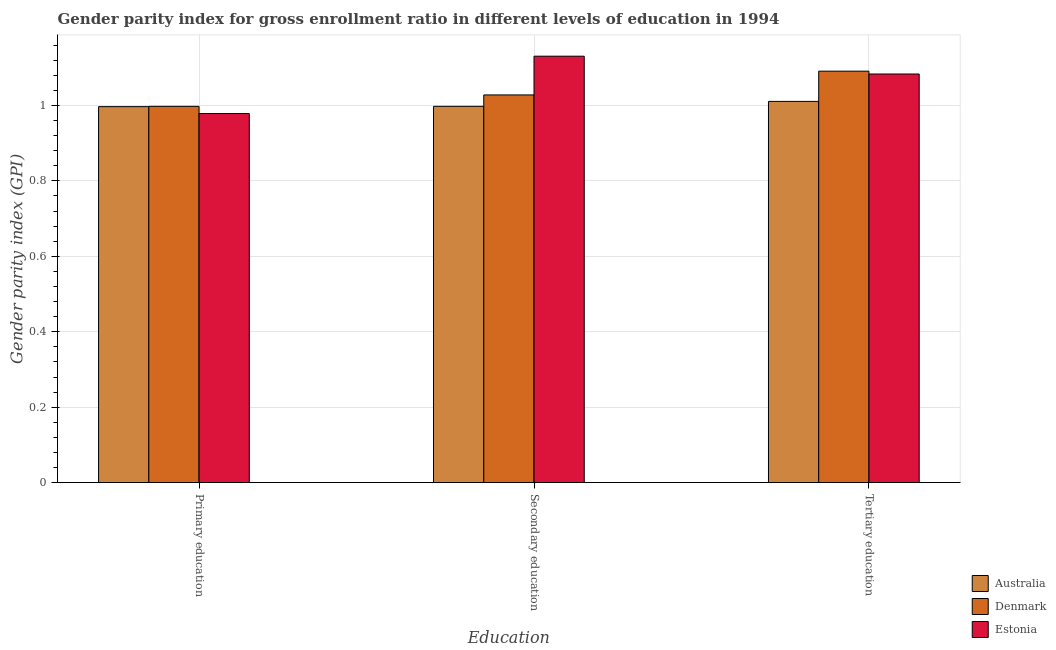How many groups of bars are there?
Ensure brevity in your answer.  3. Are the number of bars on each tick of the X-axis equal?
Your response must be concise. Yes. How many bars are there on the 3rd tick from the left?
Offer a terse response. 3. How many bars are there on the 2nd tick from the right?
Make the answer very short. 3. What is the label of the 3rd group of bars from the left?
Offer a very short reply. Tertiary education. What is the gender parity index in primary education in Denmark?
Your response must be concise. 1. Across all countries, what is the maximum gender parity index in tertiary education?
Make the answer very short. 1.09. Across all countries, what is the minimum gender parity index in secondary education?
Provide a short and direct response. 1. In which country was the gender parity index in tertiary education maximum?
Provide a short and direct response. Denmark. In which country was the gender parity index in tertiary education minimum?
Make the answer very short. Australia. What is the total gender parity index in secondary education in the graph?
Provide a succinct answer. 3.16. What is the difference between the gender parity index in tertiary education in Australia and that in Denmark?
Your answer should be compact. -0.08. What is the difference between the gender parity index in primary education in Denmark and the gender parity index in secondary education in Estonia?
Ensure brevity in your answer.  -0.13. What is the average gender parity index in tertiary education per country?
Offer a terse response. 1.06. What is the difference between the gender parity index in primary education and gender parity index in secondary education in Denmark?
Your response must be concise. -0.03. In how many countries, is the gender parity index in secondary education greater than 0.08 ?
Provide a succinct answer. 3. What is the ratio of the gender parity index in secondary education in Estonia to that in Australia?
Make the answer very short. 1.13. What is the difference between the highest and the second highest gender parity index in primary education?
Offer a terse response. 0. What is the difference between the highest and the lowest gender parity index in primary education?
Provide a short and direct response. 0.02. Is the sum of the gender parity index in secondary education in Denmark and Estonia greater than the maximum gender parity index in primary education across all countries?
Your answer should be very brief. Yes. What does the 3rd bar from the left in Primary education represents?
Give a very brief answer. Estonia. Are all the bars in the graph horizontal?
Offer a very short reply. No. Where does the legend appear in the graph?
Offer a very short reply. Bottom right. How are the legend labels stacked?
Ensure brevity in your answer.  Vertical. What is the title of the graph?
Make the answer very short. Gender parity index for gross enrollment ratio in different levels of education in 1994. What is the label or title of the X-axis?
Offer a very short reply. Education. What is the label or title of the Y-axis?
Offer a very short reply. Gender parity index (GPI). What is the Gender parity index (GPI) in Australia in Primary education?
Keep it short and to the point. 1. What is the Gender parity index (GPI) in Denmark in Primary education?
Provide a succinct answer. 1. What is the Gender parity index (GPI) in Estonia in Primary education?
Keep it short and to the point. 0.98. What is the Gender parity index (GPI) in Australia in Secondary education?
Make the answer very short. 1. What is the Gender parity index (GPI) in Denmark in Secondary education?
Keep it short and to the point. 1.03. What is the Gender parity index (GPI) of Estonia in Secondary education?
Provide a short and direct response. 1.13. What is the Gender parity index (GPI) of Australia in Tertiary education?
Make the answer very short. 1.01. What is the Gender parity index (GPI) of Denmark in Tertiary education?
Your response must be concise. 1.09. What is the Gender parity index (GPI) in Estonia in Tertiary education?
Keep it short and to the point. 1.08. Across all Education, what is the maximum Gender parity index (GPI) of Australia?
Your answer should be very brief. 1.01. Across all Education, what is the maximum Gender parity index (GPI) in Denmark?
Provide a short and direct response. 1.09. Across all Education, what is the maximum Gender parity index (GPI) in Estonia?
Keep it short and to the point. 1.13. Across all Education, what is the minimum Gender parity index (GPI) in Australia?
Make the answer very short. 1. Across all Education, what is the minimum Gender parity index (GPI) of Denmark?
Give a very brief answer. 1. Across all Education, what is the minimum Gender parity index (GPI) in Estonia?
Make the answer very short. 0.98. What is the total Gender parity index (GPI) in Australia in the graph?
Offer a very short reply. 3.01. What is the total Gender parity index (GPI) of Denmark in the graph?
Provide a short and direct response. 3.12. What is the total Gender parity index (GPI) in Estonia in the graph?
Your response must be concise. 3.19. What is the difference between the Gender parity index (GPI) of Australia in Primary education and that in Secondary education?
Keep it short and to the point. -0. What is the difference between the Gender parity index (GPI) of Denmark in Primary education and that in Secondary education?
Provide a short and direct response. -0.03. What is the difference between the Gender parity index (GPI) in Estonia in Primary education and that in Secondary education?
Ensure brevity in your answer.  -0.15. What is the difference between the Gender parity index (GPI) of Australia in Primary education and that in Tertiary education?
Provide a short and direct response. -0.01. What is the difference between the Gender parity index (GPI) of Denmark in Primary education and that in Tertiary education?
Your answer should be very brief. -0.09. What is the difference between the Gender parity index (GPI) of Estonia in Primary education and that in Tertiary education?
Give a very brief answer. -0.1. What is the difference between the Gender parity index (GPI) of Australia in Secondary education and that in Tertiary education?
Your response must be concise. -0.01. What is the difference between the Gender parity index (GPI) of Denmark in Secondary education and that in Tertiary education?
Keep it short and to the point. -0.06. What is the difference between the Gender parity index (GPI) of Estonia in Secondary education and that in Tertiary education?
Make the answer very short. 0.05. What is the difference between the Gender parity index (GPI) of Australia in Primary education and the Gender parity index (GPI) of Denmark in Secondary education?
Your answer should be very brief. -0.03. What is the difference between the Gender parity index (GPI) of Australia in Primary education and the Gender parity index (GPI) of Estonia in Secondary education?
Ensure brevity in your answer.  -0.13. What is the difference between the Gender parity index (GPI) of Denmark in Primary education and the Gender parity index (GPI) of Estonia in Secondary education?
Keep it short and to the point. -0.13. What is the difference between the Gender parity index (GPI) of Australia in Primary education and the Gender parity index (GPI) of Denmark in Tertiary education?
Keep it short and to the point. -0.09. What is the difference between the Gender parity index (GPI) in Australia in Primary education and the Gender parity index (GPI) in Estonia in Tertiary education?
Offer a very short reply. -0.09. What is the difference between the Gender parity index (GPI) of Denmark in Primary education and the Gender parity index (GPI) of Estonia in Tertiary education?
Your answer should be very brief. -0.09. What is the difference between the Gender parity index (GPI) in Australia in Secondary education and the Gender parity index (GPI) in Denmark in Tertiary education?
Your answer should be very brief. -0.09. What is the difference between the Gender parity index (GPI) in Australia in Secondary education and the Gender parity index (GPI) in Estonia in Tertiary education?
Provide a succinct answer. -0.09. What is the difference between the Gender parity index (GPI) in Denmark in Secondary education and the Gender parity index (GPI) in Estonia in Tertiary education?
Keep it short and to the point. -0.06. What is the average Gender parity index (GPI) in Denmark per Education?
Provide a short and direct response. 1.04. What is the average Gender parity index (GPI) in Estonia per Education?
Give a very brief answer. 1.06. What is the difference between the Gender parity index (GPI) in Australia and Gender parity index (GPI) in Denmark in Primary education?
Keep it short and to the point. -0. What is the difference between the Gender parity index (GPI) of Australia and Gender parity index (GPI) of Estonia in Primary education?
Provide a succinct answer. 0.02. What is the difference between the Gender parity index (GPI) in Denmark and Gender parity index (GPI) in Estonia in Primary education?
Provide a short and direct response. 0.02. What is the difference between the Gender parity index (GPI) of Australia and Gender parity index (GPI) of Denmark in Secondary education?
Ensure brevity in your answer.  -0.03. What is the difference between the Gender parity index (GPI) in Australia and Gender parity index (GPI) in Estonia in Secondary education?
Give a very brief answer. -0.13. What is the difference between the Gender parity index (GPI) in Denmark and Gender parity index (GPI) in Estonia in Secondary education?
Ensure brevity in your answer.  -0.1. What is the difference between the Gender parity index (GPI) in Australia and Gender parity index (GPI) in Denmark in Tertiary education?
Give a very brief answer. -0.08. What is the difference between the Gender parity index (GPI) of Australia and Gender parity index (GPI) of Estonia in Tertiary education?
Your answer should be compact. -0.07. What is the difference between the Gender parity index (GPI) of Denmark and Gender parity index (GPI) of Estonia in Tertiary education?
Ensure brevity in your answer.  0.01. What is the ratio of the Gender parity index (GPI) in Denmark in Primary education to that in Secondary education?
Your answer should be very brief. 0.97. What is the ratio of the Gender parity index (GPI) in Estonia in Primary education to that in Secondary education?
Your answer should be very brief. 0.87. What is the ratio of the Gender parity index (GPI) of Australia in Primary education to that in Tertiary education?
Keep it short and to the point. 0.99. What is the ratio of the Gender parity index (GPI) in Denmark in Primary education to that in Tertiary education?
Provide a short and direct response. 0.91. What is the ratio of the Gender parity index (GPI) in Estonia in Primary education to that in Tertiary education?
Your answer should be very brief. 0.9. What is the ratio of the Gender parity index (GPI) of Australia in Secondary education to that in Tertiary education?
Ensure brevity in your answer.  0.99. What is the ratio of the Gender parity index (GPI) of Denmark in Secondary education to that in Tertiary education?
Your answer should be very brief. 0.94. What is the ratio of the Gender parity index (GPI) in Estonia in Secondary education to that in Tertiary education?
Your response must be concise. 1.04. What is the difference between the highest and the second highest Gender parity index (GPI) of Australia?
Make the answer very short. 0.01. What is the difference between the highest and the second highest Gender parity index (GPI) of Denmark?
Offer a terse response. 0.06. What is the difference between the highest and the second highest Gender parity index (GPI) in Estonia?
Make the answer very short. 0.05. What is the difference between the highest and the lowest Gender parity index (GPI) in Australia?
Provide a short and direct response. 0.01. What is the difference between the highest and the lowest Gender parity index (GPI) of Denmark?
Make the answer very short. 0.09. What is the difference between the highest and the lowest Gender parity index (GPI) in Estonia?
Provide a short and direct response. 0.15. 